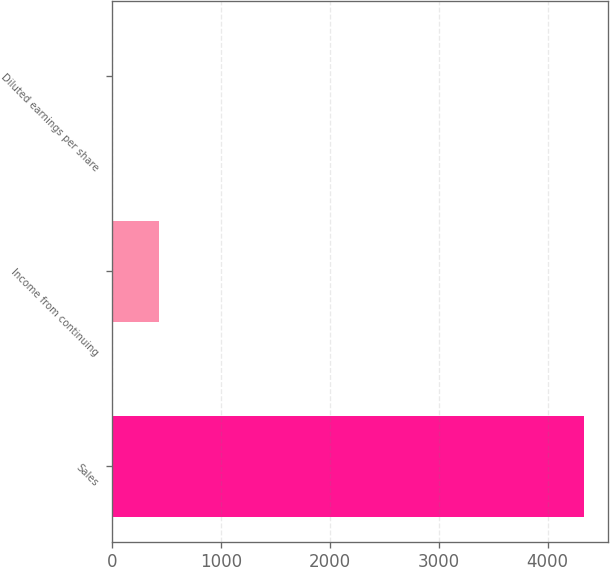<chart> <loc_0><loc_0><loc_500><loc_500><bar_chart><fcel>Sales<fcel>Income from continuing<fcel>Diluted earnings per share<nl><fcel>4332.5<fcel>434.63<fcel>1.53<nl></chart> 